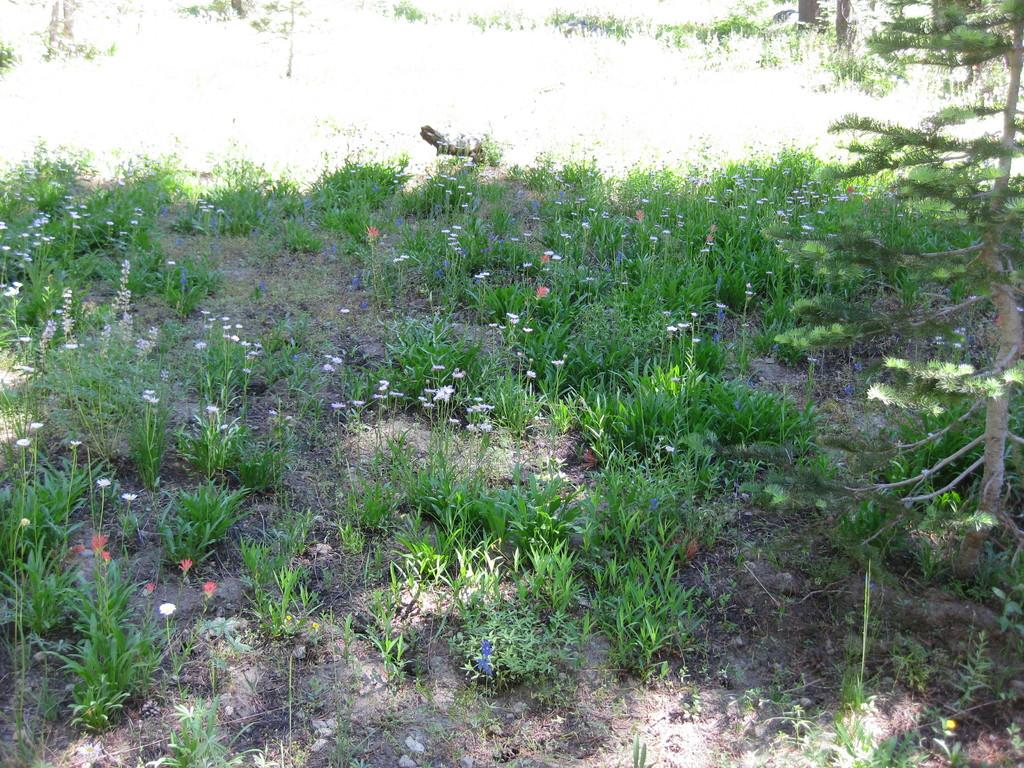What type of living organisms can be seen in the image? Plants and flowers are visible in the image. What other type of living organism can be seen in the image? There is a bird in the image. Can you describe the bird in the image? The bird is black in color. What type of wire is being used by the flowers in the image? There is no wire present in the image; the flowers are attached to the plants. What type of discussion is taking place between the plants in the image? Plants do not have the ability to engage in discussions, so there is no discussion taking place between them in the image. 